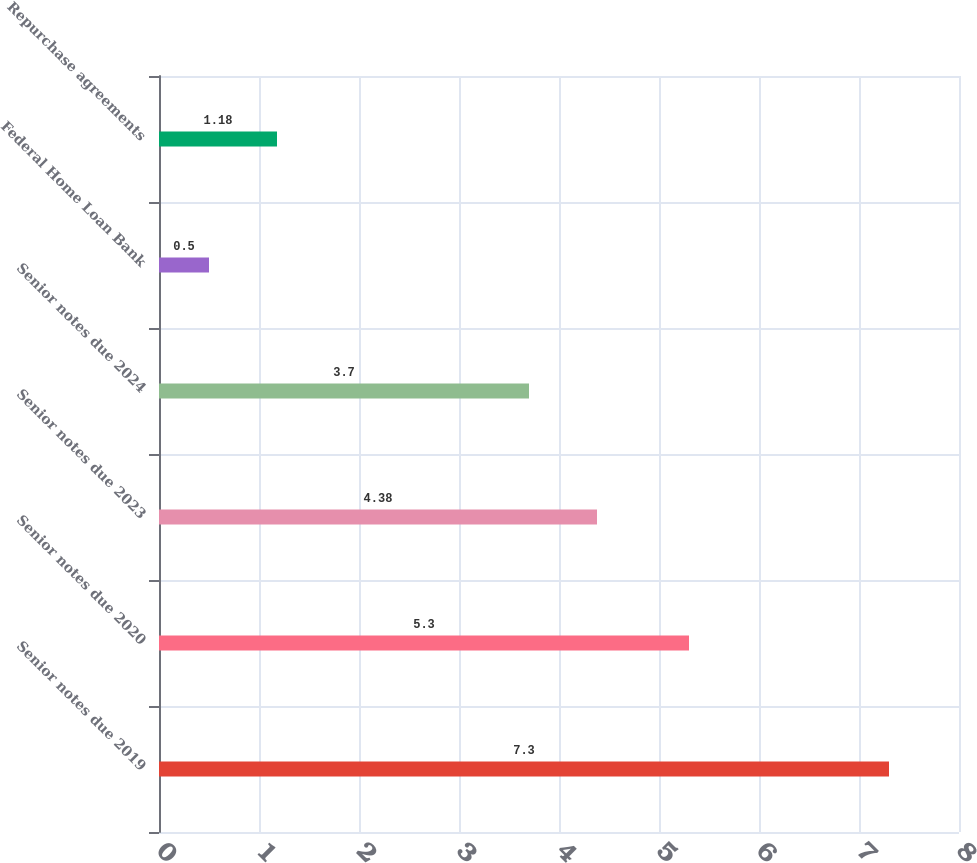<chart> <loc_0><loc_0><loc_500><loc_500><bar_chart><fcel>Senior notes due 2019<fcel>Senior notes due 2020<fcel>Senior notes due 2023<fcel>Senior notes due 2024<fcel>Federal Home Loan Bank<fcel>Repurchase agreements<nl><fcel>7.3<fcel>5.3<fcel>4.38<fcel>3.7<fcel>0.5<fcel>1.18<nl></chart> 